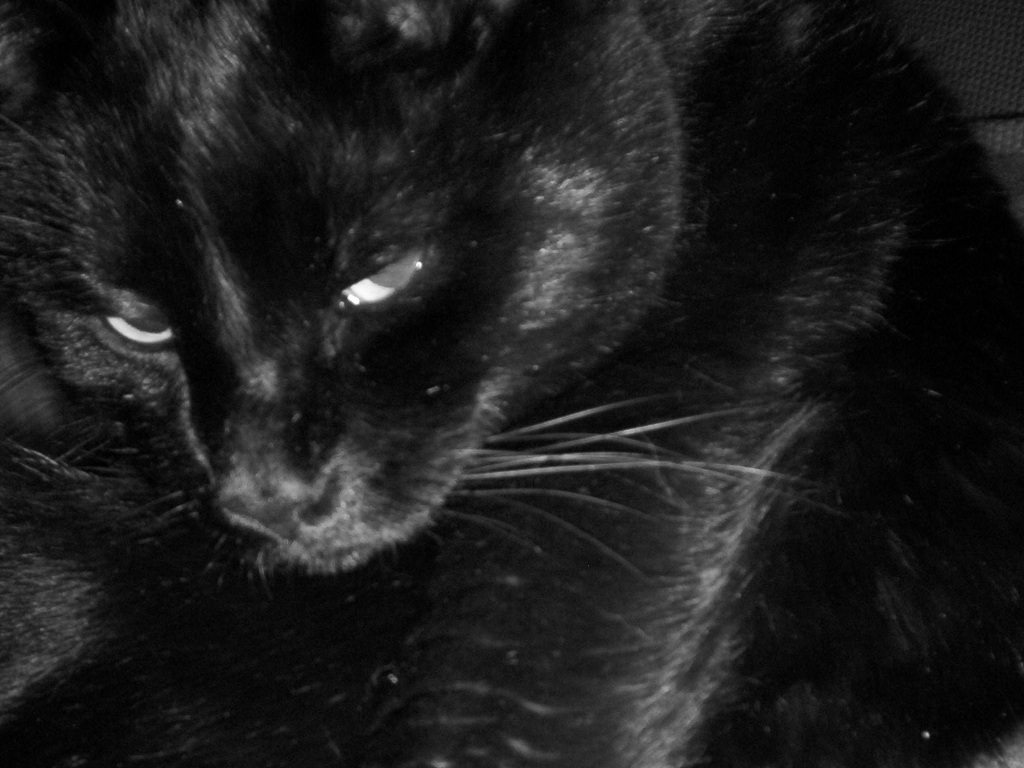Could you describe the main subject of this image? The main subject of this image is a black cat. The cat's fur texture is visible, and its eyes are sharply in focus, reflecting a hint of light. The close-up shot emphasizes the feline features, creating an intimate portrait. Does the cat seem to be in its natural habitat, or is this a domestic setting? Given the soft texture visible in the background that might be a piece of furniture or fabric, the cat appears to be in a domestic setting. There are no obvious elements to suggest it is outdoors or in a natural habitat. 